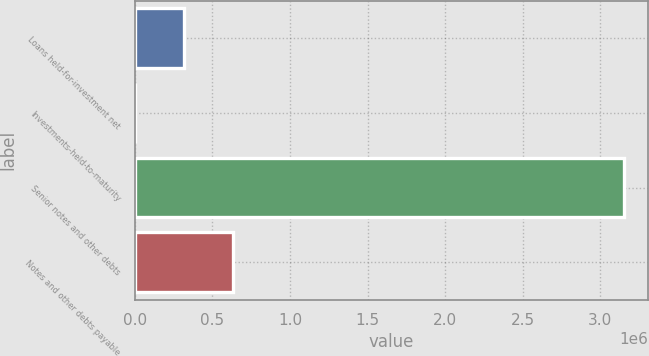<chart> <loc_0><loc_0><loc_500><loc_500><bar_chart><fcel>Loans held-for-investment net<fcel>Investments-held-to-maturity<fcel>Senior notes and other debts<fcel>Notes and other debts payable<nl><fcel>318170<fcel>3177<fcel>3.15311e+06<fcel>633163<nl></chart> 